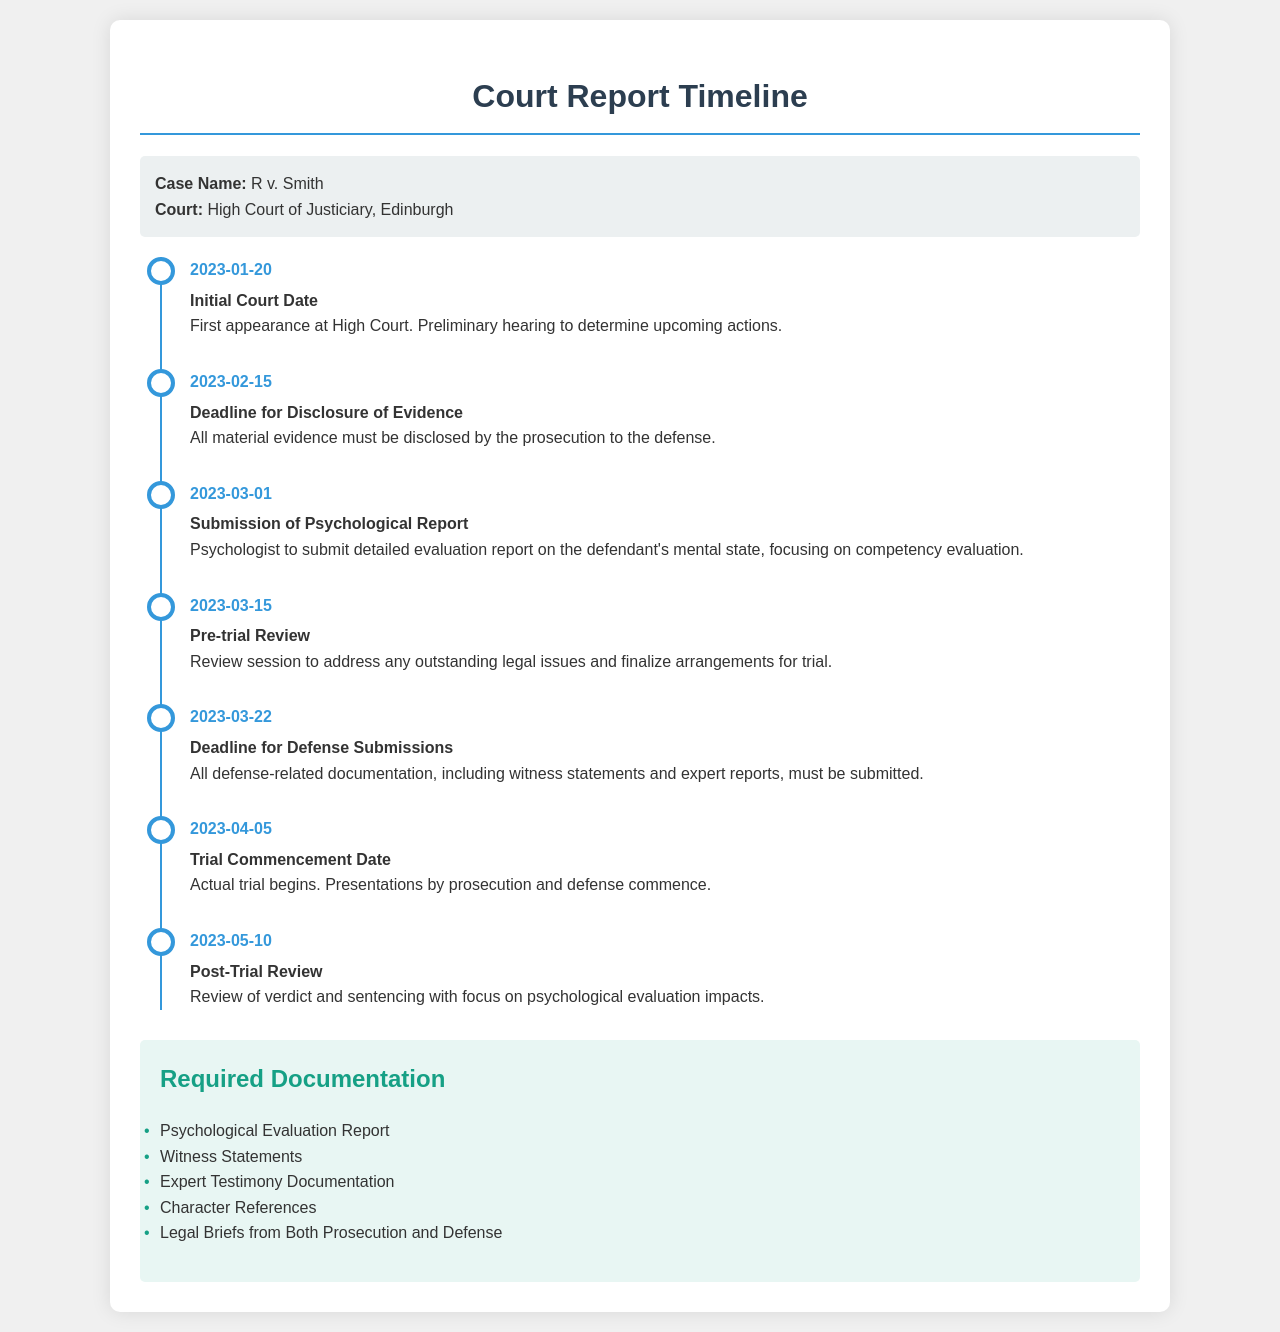what is the initial court date? The initial court date is the first appearance at High Court as mentioned in the timeline.
Answer: 2023-01-20 when is the deadline for disclosure of evidence? The deadline for disclosure of evidence is specified in the timeline under a specific event.
Answer: 2023-02-15 what is required to be submitted by the psychologist? The psychologist is required to submit a detailed evaluation report focusing on competency evaluation.
Answer: Psychological Report what event occurs on March 15, 2023? The event on March 15, 2023, is a review session to finalize arrangements for trial, as indicated in the document.
Answer: Pre-trial Review how many days after the psychological report submission does the trial commence? The trial begins on April 5, 2023, which is a specific number of days after the psychological report submission date noted in the timeline.
Answer: 26 days what type of report is required for post-trial review? The post-trial review focuses on the psychological evaluation impacts, which is elaborated in the document.
Answer: Psychological evaluation how many types of documentation are listed as required? The document lists various types of documentation needed for the case, which can be counted directly from the list.
Answer: 5 what is the title of the court where the case is being heard? The title of the court is provided at the beginning of the document under case information.
Answer: High Court of Justiciary what is the last event date mentioned in the timeline? The last event in the timeline indicates the final date for an important review session after the trial.
Answer: 2023-05-10 